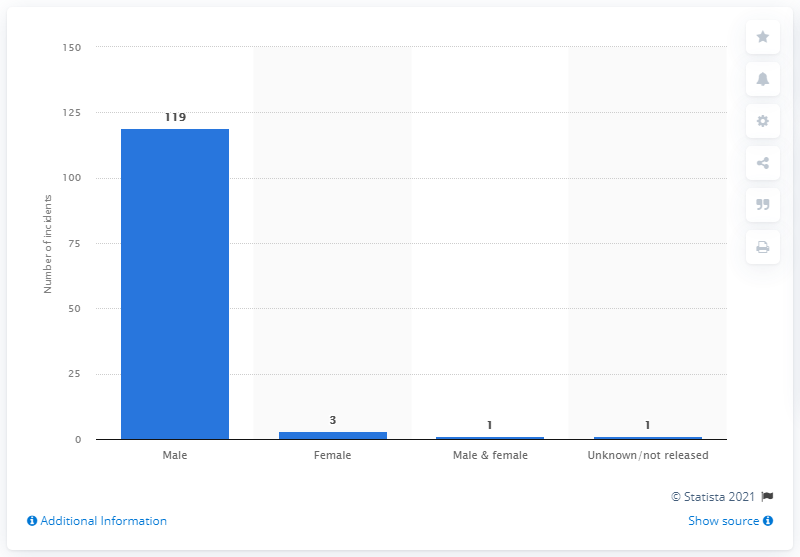Mention a couple of crucial points in this snapshot. Since 1982, there have been 119 mass shootings in the United States. 